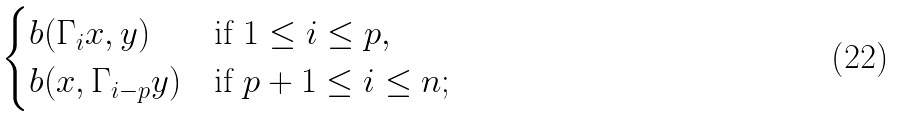Convert formula to latex. <formula><loc_0><loc_0><loc_500><loc_500>\begin{cases} b ( \Gamma _ { i } x , y ) & \text {if } 1 \leq i \leq p , \\ b ( x , \Gamma _ { i - p } y ) & \text {if } p + 1 \leq i \leq n ; \end{cases}</formula> 